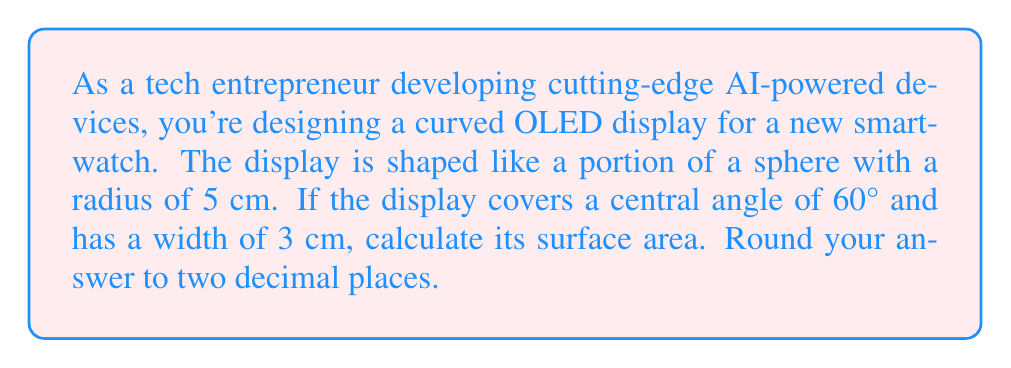Teach me how to tackle this problem. To solve this problem, we need to use the formula for the surface area of a spherical cap and adjust it for the width of the display. Let's break it down step-by-step:

1. The formula for the surface area of a spherical cap is:
   $$A = 2\pi rh$$
   where $r$ is the radius of the sphere and $h$ is the height of the cap.

2. We need to find $h$ using the central angle $\theta$ (in radians):
   $$h = r(1 - \cos(\frac{\theta}{2}))$$
   
3. Convert 60° to radians:
   $$\theta = 60° \cdot \frac{\pi}{180°} = \frac{\pi}{3}$$

4. Calculate $h$:
   $$h = 5(1 - \cos(\frac{\pi}{6})) \approx 0.3407 \text{ cm}$$

5. Now we can calculate the surface area of the full spherical cap:
   $$A_{full} = 2\pi rh = 2\pi \cdot 5 \cdot 0.3407 \approx 10.6988 \text{ cm}^2$$

6. However, our display has a width of 3 cm. We need to adjust the area proportionally:
   $$\text{Proportion} = \frac{\text{Width}}{\text{Circumference}} = \frac{3}{2\pi r} = \frac{3}{10\pi}$$

7. Calculate the final surface area:
   $$A_{display} = A_{full} \cdot \frac{3}{10\pi} \approx 10.6988 \cdot 0.0955 \approx 1.0217 \text{ cm}^2$$

8. Rounding to two decimal places:
   $$A_{display} \approx 1.02 \text{ cm}^2$$

[asy]
import geometry;

unitsize(1cm);

real r = 5;
real theta = 60*pi/180;
real h = r*(1-cos(theta/2));
real w = 3;

path arc = arc((0,0), r, 90-theta/2, 90+theta/2);
draw(arc);
draw((0,0)--(r*cos(theta/2), r*sin(theta/2)));
draw((0,0)--(r*cos(-theta/2), r*sin(-theta/2)));
draw((0,r)--(0,r+h), dashed);
draw((-w/2,r)--(w/2,r));

label("$r$", (r/2,0), S);
label("$h$", (0,r+h/2), E);
label("$w$", (0,r), N);
label("$\theta$", (0,0), NE);
[/asy]
Answer: The surface area of the curved OLED display is approximately 1.02 cm². 